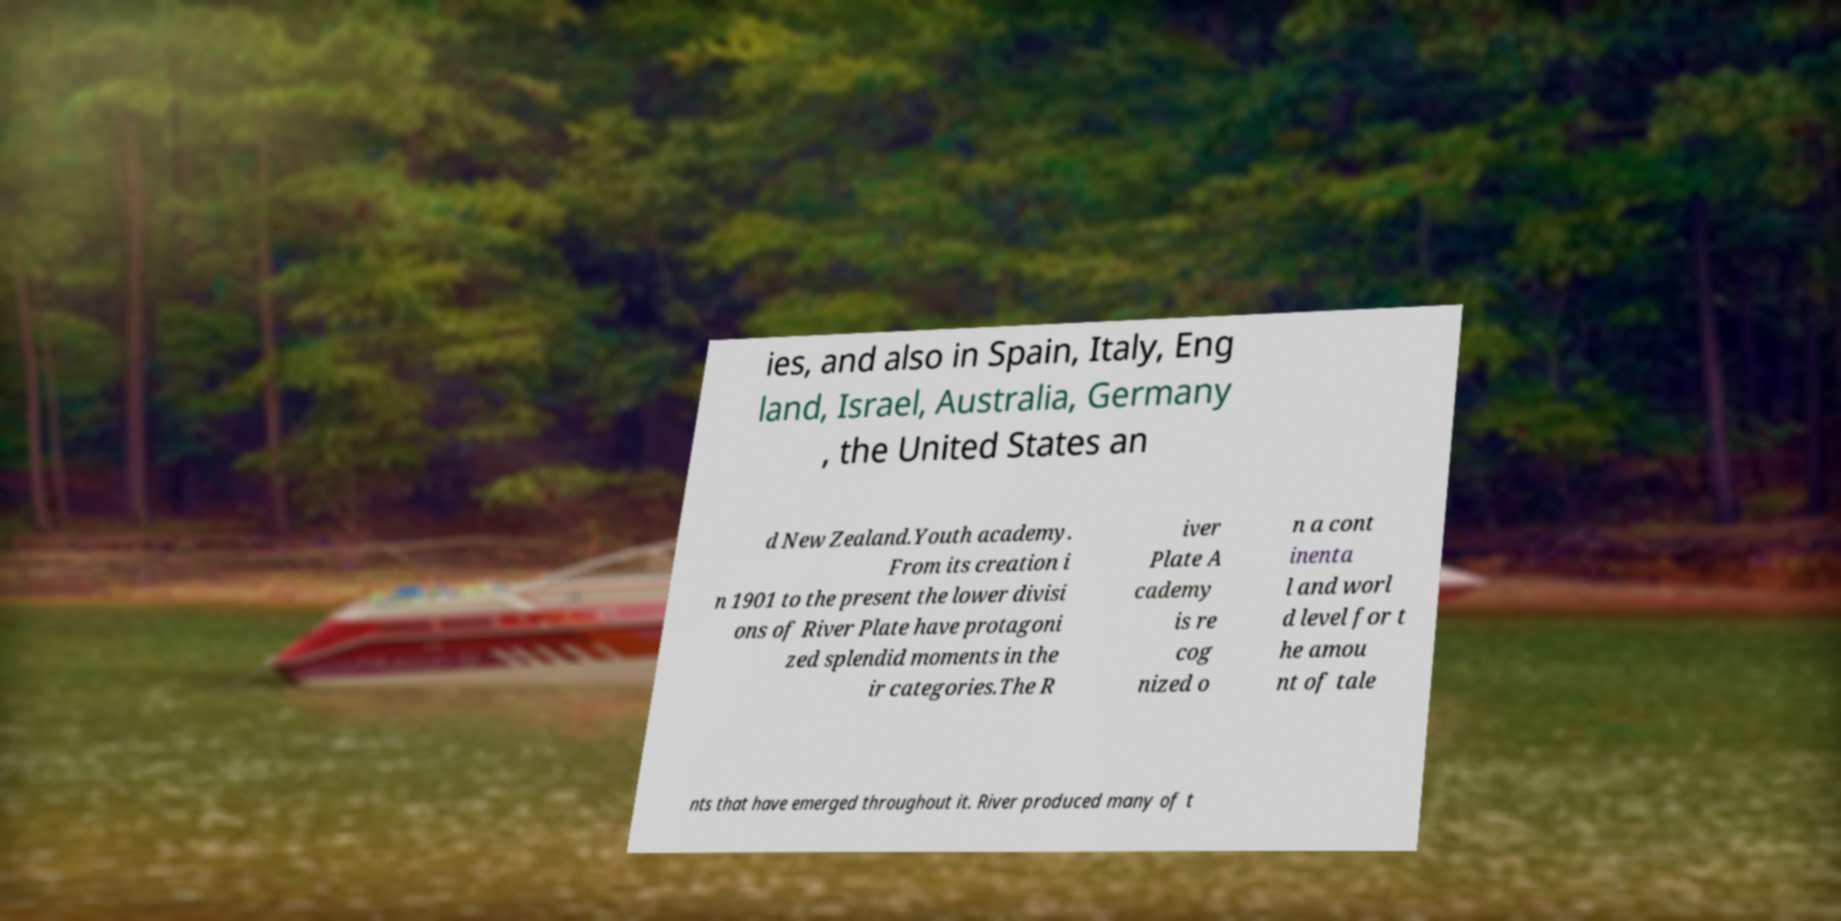Please identify and transcribe the text found in this image. ies, and also in Spain, Italy, Eng land, Israel, Australia, Germany , the United States an d New Zealand.Youth academy. From its creation i n 1901 to the present the lower divisi ons of River Plate have protagoni zed splendid moments in the ir categories.The R iver Plate A cademy is re cog nized o n a cont inenta l and worl d level for t he amou nt of tale nts that have emerged throughout it. River produced many of t 